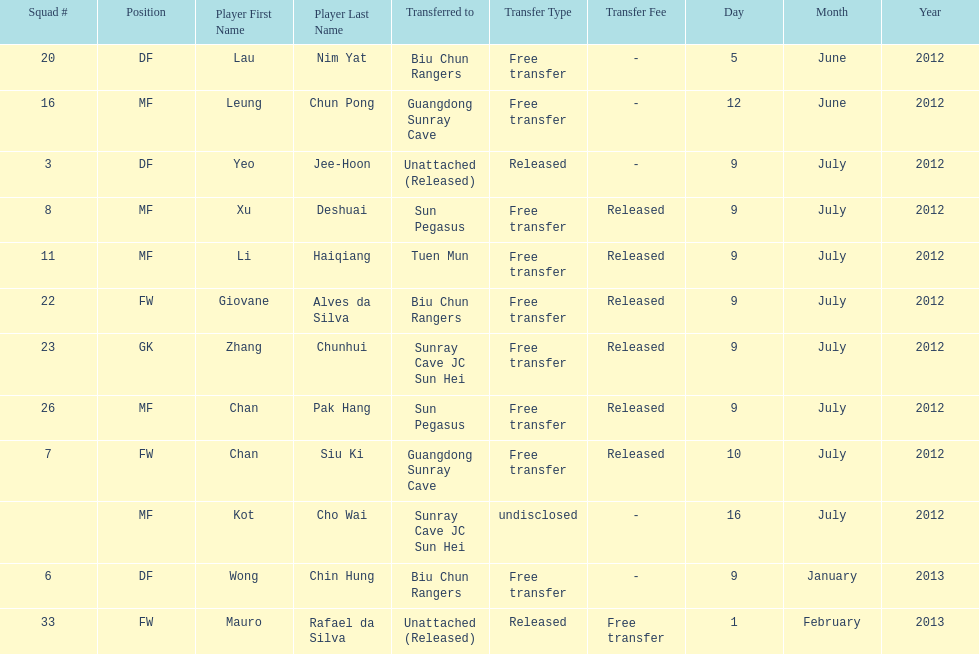What is the total number of players listed? 12. 